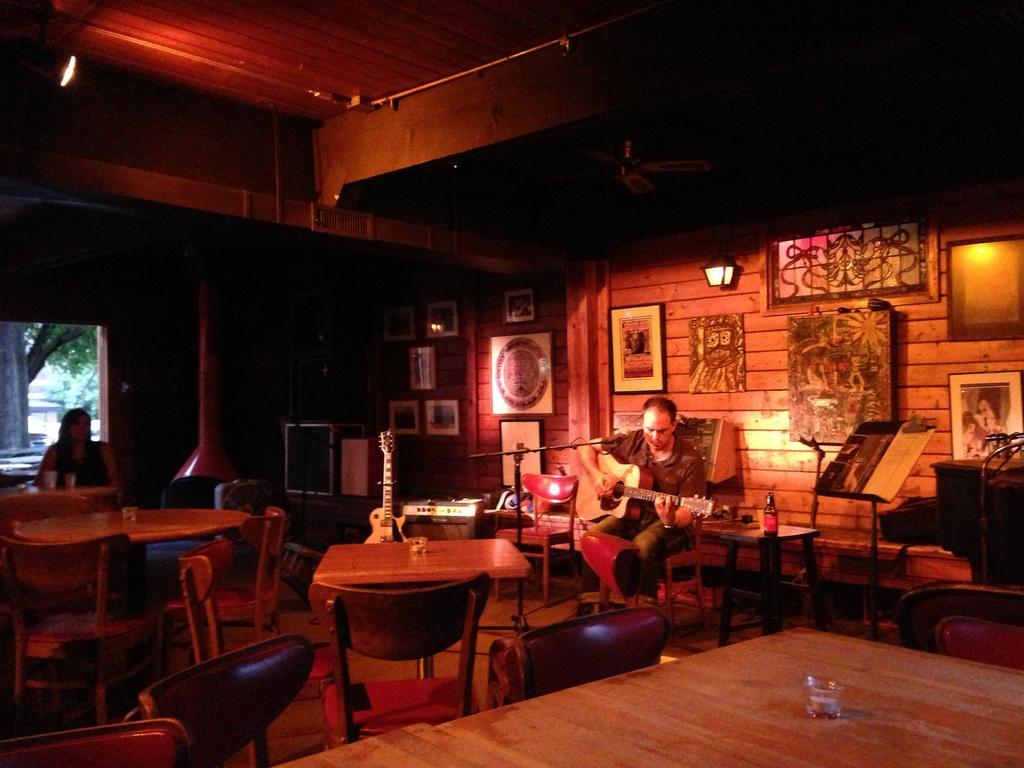Describe this image in one or two sentences. In this image I can see the person is holding the guitar and sitting on the chair. I can see the mic, stand, few chairs, tables, lights, musical instruments, trees, few objects around. I can see one person is sitting on the chair. 